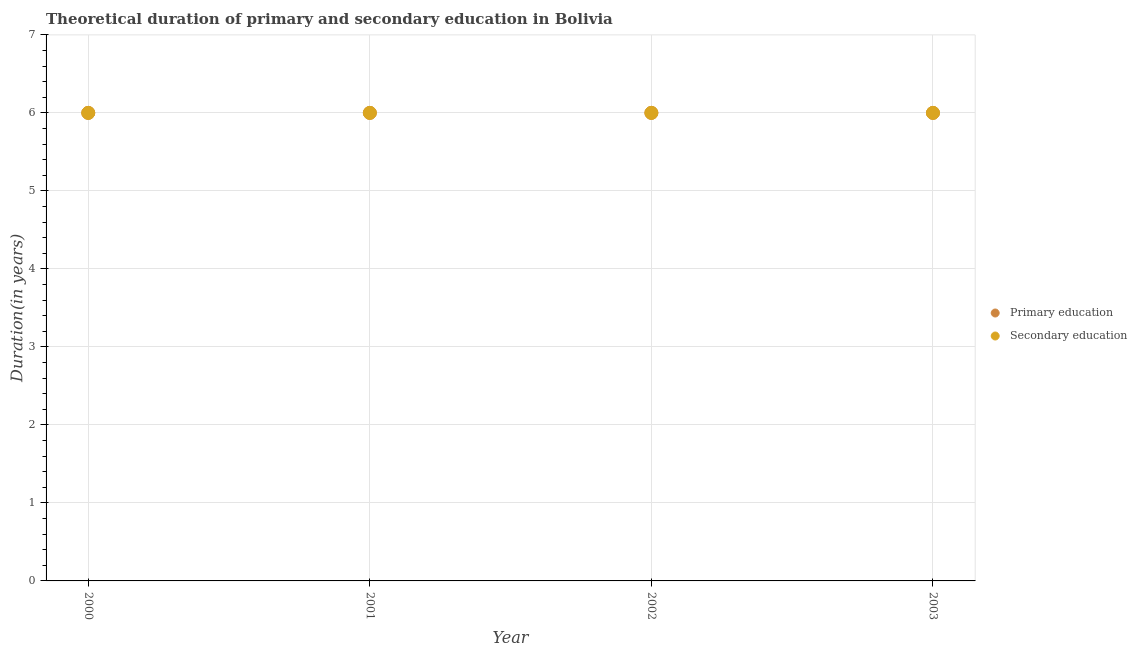Is the number of dotlines equal to the number of legend labels?
Your answer should be very brief. Yes. In which year was the duration of primary education minimum?
Keep it short and to the point. 2000. What is the total duration of secondary education in the graph?
Offer a terse response. 24. What is the difference between the duration of primary education in 2003 and the duration of secondary education in 2000?
Your answer should be very brief. 0. What is the average duration of secondary education per year?
Ensure brevity in your answer.  6. What is the ratio of the duration of secondary education in 2000 to that in 2002?
Give a very brief answer. 1. Is the duration of primary education in 2000 less than that in 2001?
Give a very brief answer. No. What is the difference between the highest and the lowest duration of secondary education?
Provide a succinct answer. 0. Does the duration of secondary education monotonically increase over the years?
Your response must be concise. No. What is the difference between two consecutive major ticks on the Y-axis?
Provide a succinct answer. 1. Are the values on the major ticks of Y-axis written in scientific E-notation?
Give a very brief answer. No. Does the graph contain any zero values?
Your answer should be very brief. No. How many legend labels are there?
Ensure brevity in your answer.  2. How are the legend labels stacked?
Provide a short and direct response. Vertical. What is the title of the graph?
Provide a short and direct response. Theoretical duration of primary and secondary education in Bolivia. Does "Under-5(female)" appear as one of the legend labels in the graph?
Your answer should be very brief. No. What is the label or title of the Y-axis?
Offer a very short reply. Duration(in years). What is the Duration(in years) of Primary education in 2000?
Provide a succinct answer. 6. What is the Duration(in years) of Primary education in 2001?
Ensure brevity in your answer.  6. What is the Duration(in years) in Primary education in 2002?
Your response must be concise. 6. Across all years, what is the maximum Duration(in years) of Primary education?
Provide a succinct answer. 6. Across all years, what is the minimum Duration(in years) of Primary education?
Your answer should be very brief. 6. What is the total Duration(in years) in Primary education in the graph?
Ensure brevity in your answer.  24. What is the difference between the Duration(in years) of Primary education in 2000 and that in 2001?
Ensure brevity in your answer.  0. What is the difference between the Duration(in years) of Secondary education in 2000 and that in 2001?
Your answer should be very brief. 0. What is the difference between the Duration(in years) in Secondary education in 2000 and that in 2002?
Your answer should be very brief. 0. What is the difference between the Duration(in years) of Primary education in 2000 and that in 2003?
Your answer should be compact. 0. What is the difference between the Duration(in years) of Primary education in 2001 and that in 2002?
Offer a very short reply. 0. What is the difference between the Duration(in years) of Secondary education in 2001 and that in 2002?
Provide a succinct answer. 0. What is the difference between the Duration(in years) in Primary education in 2002 and that in 2003?
Ensure brevity in your answer.  0. What is the difference between the Duration(in years) of Primary education in 2000 and the Duration(in years) of Secondary education in 2001?
Ensure brevity in your answer.  0. What is the difference between the Duration(in years) of Primary education in 2000 and the Duration(in years) of Secondary education in 2002?
Offer a terse response. 0. What is the difference between the Duration(in years) in Primary education in 2000 and the Duration(in years) in Secondary education in 2003?
Provide a succinct answer. 0. What is the difference between the Duration(in years) in Primary education in 2001 and the Duration(in years) in Secondary education in 2002?
Your answer should be very brief. 0. What is the difference between the Duration(in years) in Primary education in 2001 and the Duration(in years) in Secondary education in 2003?
Make the answer very short. 0. What is the difference between the Duration(in years) in Primary education in 2002 and the Duration(in years) in Secondary education in 2003?
Keep it short and to the point. 0. What is the average Duration(in years) in Primary education per year?
Make the answer very short. 6. In the year 2000, what is the difference between the Duration(in years) of Primary education and Duration(in years) of Secondary education?
Keep it short and to the point. 0. In the year 2001, what is the difference between the Duration(in years) of Primary education and Duration(in years) of Secondary education?
Offer a terse response. 0. In the year 2003, what is the difference between the Duration(in years) of Primary education and Duration(in years) of Secondary education?
Ensure brevity in your answer.  0. What is the ratio of the Duration(in years) of Secondary education in 2000 to that in 2001?
Keep it short and to the point. 1. What is the ratio of the Duration(in years) of Secondary education in 2000 to that in 2002?
Make the answer very short. 1. What is the ratio of the Duration(in years) in Primary education in 2000 to that in 2003?
Ensure brevity in your answer.  1. What is the ratio of the Duration(in years) of Primary education in 2001 to that in 2002?
Make the answer very short. 1. What is the ratio of the Duration(in years) of Secondary education in 2001 to that in 2003?
Ensure brevity in your answer.  1. What is the ratio of the Duration(in years) in Primary education in 2002 to that in 2003?
Your answer should be very brief. 1. What is the ratio of the Duration(in years) of Secondary education in 2002 to that in 2003?
Ensure brevity in your answer.  1. What is the difference between the highest and the second highest Duration(in years) in Primary education?
Your response must be concise. 0. What is the difference between the highest and the second highest Duration(in years) in Secondary education?
Your answer should be compact. 0. What is the difference between the highest and the lowest Duration(in years) in Primary education?
Make the answer very short. 0. What is the difference between the highest and the lowest Duration(in years) of Secondary education?
Your answer should be very brief. 0. 